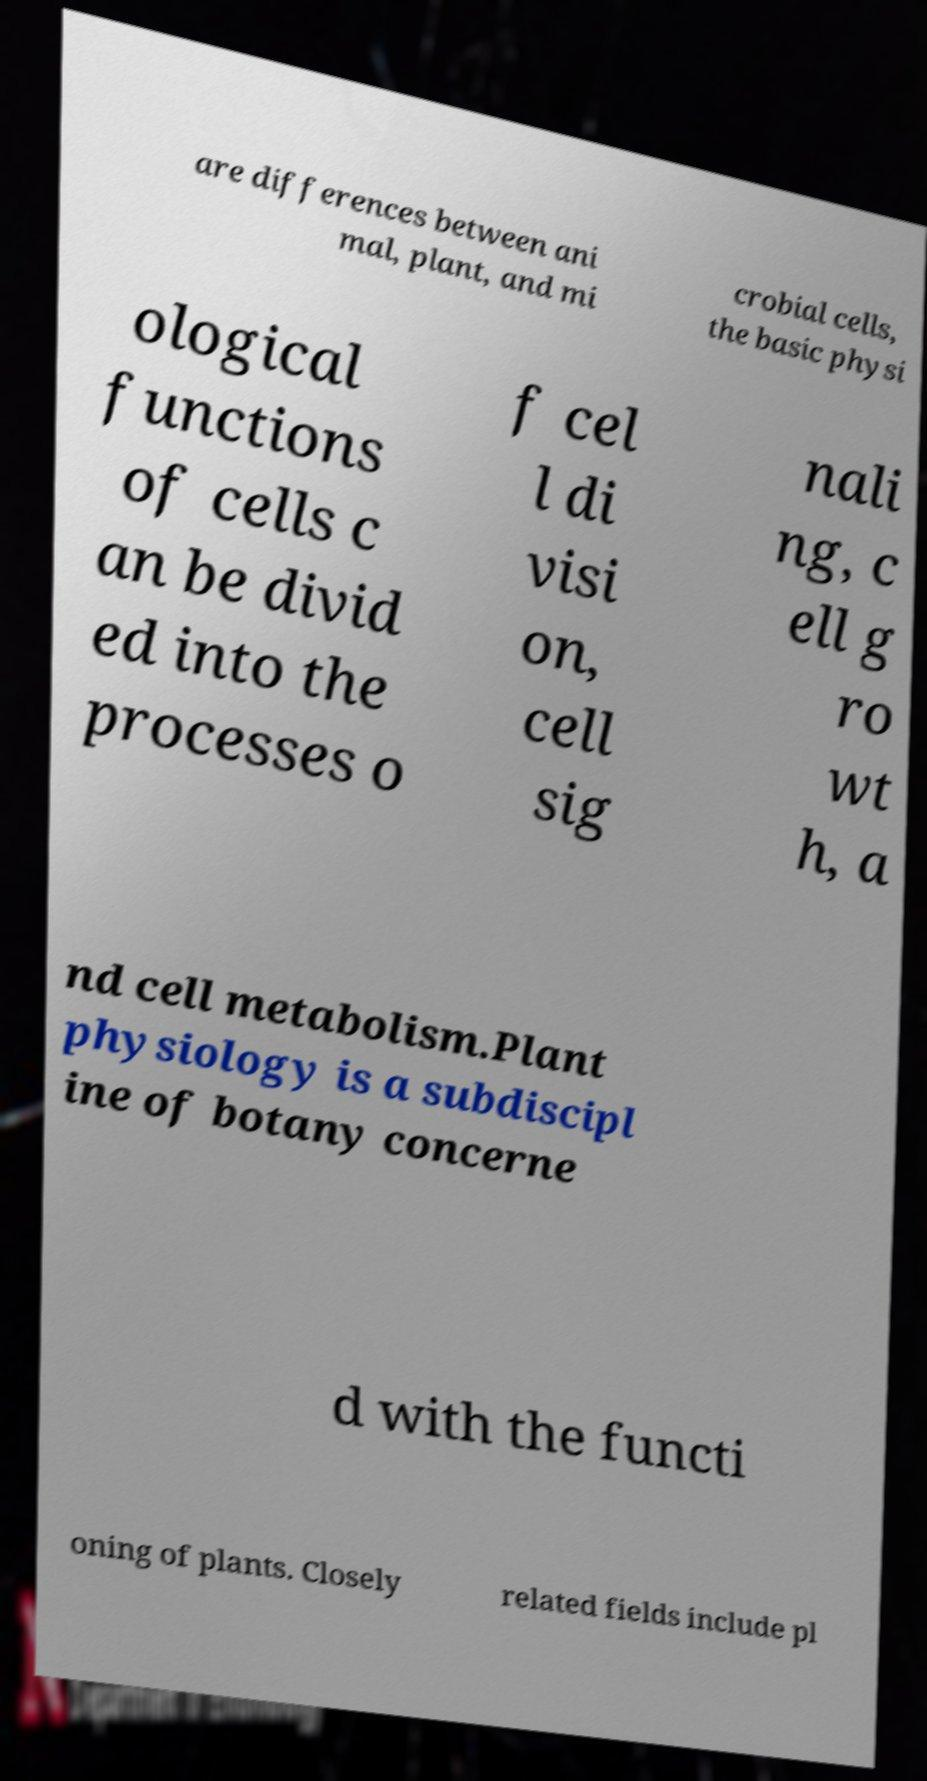What messages or text are displayed in this image? I need them in a readable, typed format. are differences between ani mal, plant, and mi crobial cells, the basic physi ological functions of cells c an be divid ed into the processes o f cel l di visi on, cell sig nali ng, c ell g ro wt h, a nd cell metabolism.Plant physiology is a subdiscipl ine of botany concerne d with the functi oning of plants. Closely related fields include pl 